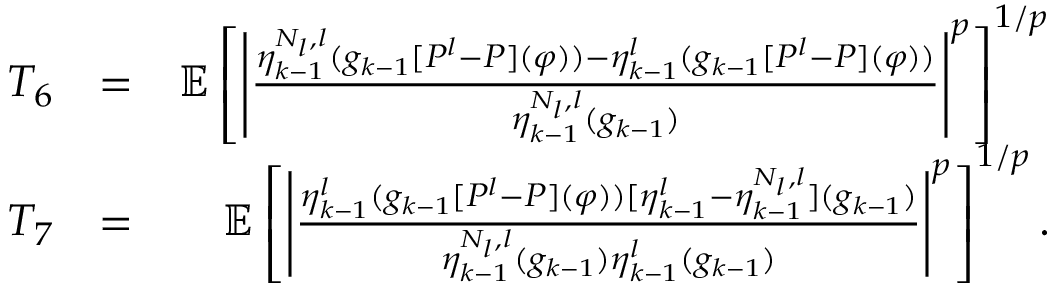<formula> <loc_0><loc_0><loc_500><loc_500>\begin{array} { r l r } { T _ { 6 } } & { = } & { \mathbb { E } \left [ \left | \frac { \eta _ { k - 1 } ^ { N _ { l } , l } ( g _ { k - 1 } [ P ^ { l } - P ] ( \varphi ) ) - \eta _ { k - 1 } ^ { l } ( g _ { k - 1 } [ P ^ { l } - P ] ( \varphi ) ) } { \eta _ { k - 1 } ^ { N _ { l } , l } ( g _ { k - 1 } ) } \right | ^ { p } \right ] ^ { 1 / p } } \\ { T _ { 7 } } & { = } & { \mathbb { E } \left [ \left | \frac { \eta _ { k - 1 } ^ { l } ( g _ { k - 1 } [ P ^ { l } - P ] ( \varphi ) ) [ \eta _ { k - 1 } ^ { l } - \eta _ { k - 1 } ^ { N _ { l } , l } ] ( g _ { k - 1 } ) } { \eta _ { k - 1 } ^ { N _ { l } , l } ( g _ { k - 1 } ) \eta _ { k - 1 } ^ { l } ( g _ { k - 1 } ) } \right | ^ { p } \right ] ^ { 1 / p } . } \end{array}</formula> 